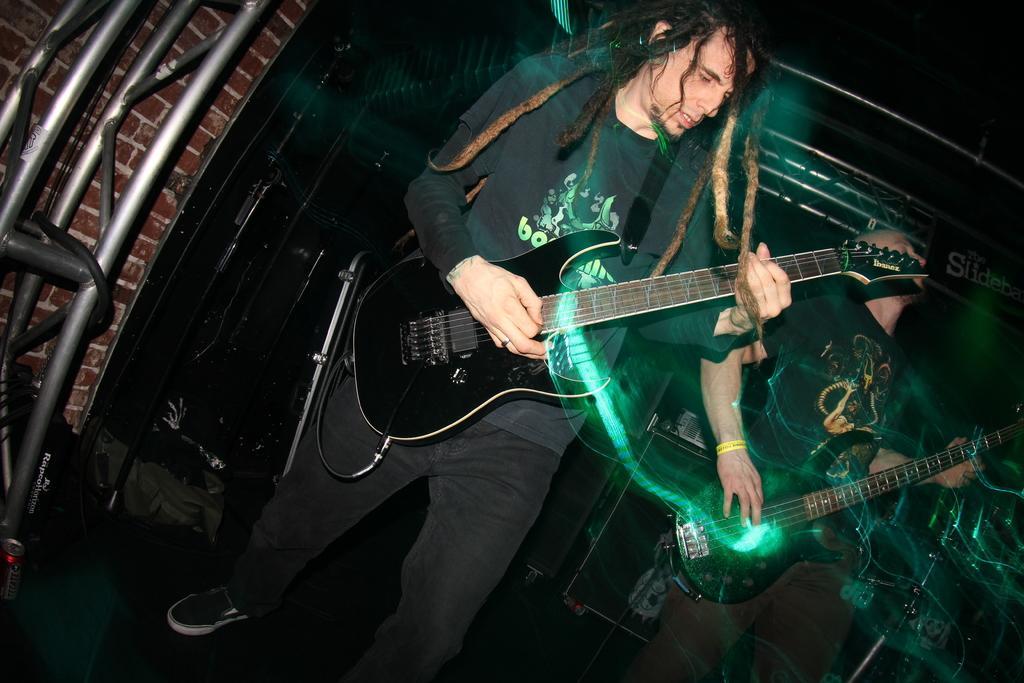In one or two sentences, can you explain what this image depicts? In the center of the image we can see two mans are standing and playing guitars. In the background of the image we can see the wall, rods, bags and some musical instruments. At the bottom of the image we can see the floor. 